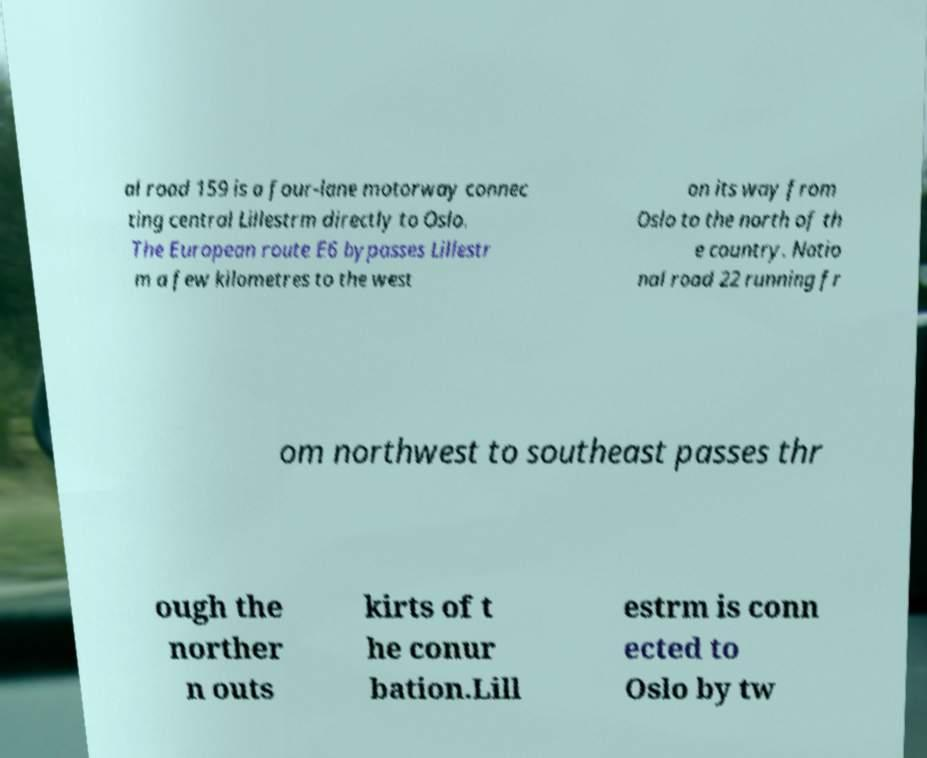Could you assist in decoding the text presented in this image and type it out clearly? al road 159 is a four-lane motorway connec ting central Lillestrm directly to Oslo. The European route E6 bypasses Lillestr m a few kilometres to the west on its way from Oslo to the north of th e country. Natio nal road 22 running fr om northwest to southeast passes thr ough the norther n outs kirts of t he conur bation.Lill estrm is conn ected to Oslo by tw 